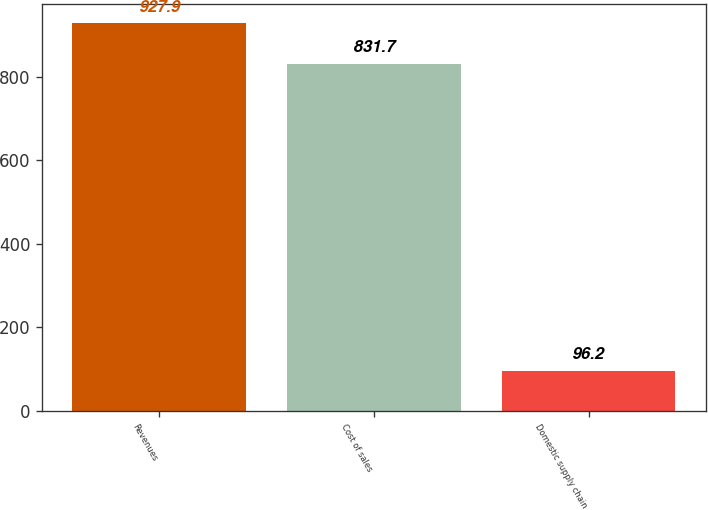Convert chart. <chart><loc_0><loc_0><loc_500><loc_500><bar_chart><fcel>Revenues<fcel>Cost of sales<fcel>Domestic supply chain<nl><fcel>927.9<fcel>831.7<fcel>96.2<nl></chart> 